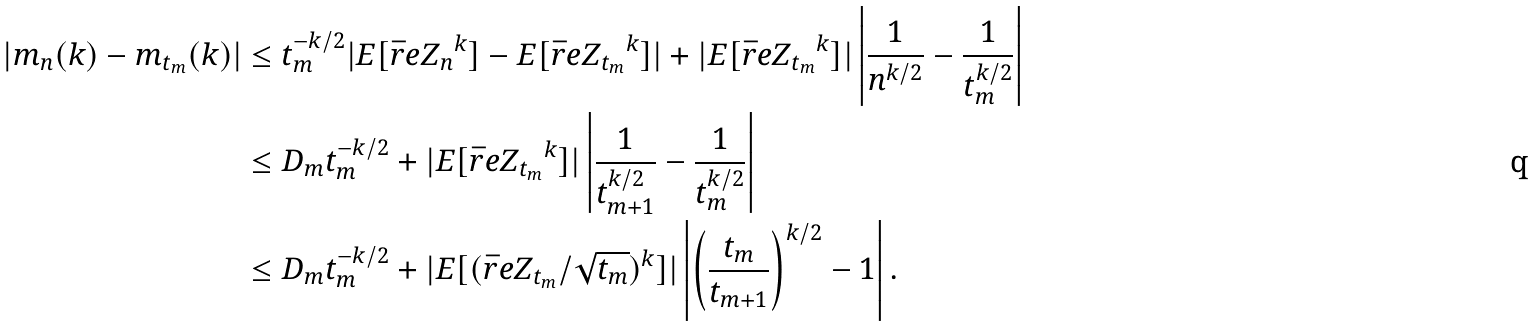Convert formula to latex. <formula><loc_0><loc_0><loc_500><loc_500>| m _ { n } ( k ) - m _ { t _ { m } } ( k ) | & \leq t _ { m } ^ { - k / 2 } | E [ \bar { r } e { Z _ { n } } ^ { k } ] - E [ \bar { r } e { Z _ { t _ { m } } } ^ { k } ] | + | E [ \bar { r } e { Z _ { t _ { m } } } ^ { k } ] | \left | \frac { 1 } { n ^ { k / 2 } } - \frac { 1 } { t _ { m } ^ { k / 2 } } \right | \\ & \leq D _ { m } t _ { m } ^ { - k / 2 } + | E [ \bar { r } e { Z _ { t _ { m } } } ^ { k } ] | \left | \frac { 1 } { t _ { m + 1 } ^ { k / 2 } } - \frac { 1 } { t _ { m } ^ { k / 2 } } \right | \\ & \leq D _ { m } t _ { m } ^ { - k / 2 } + | E [ ( \bar { r } e { Z _ { t _ { m } } } / \sqrt { t _ { m } } ) ^ { k } ] | \left | \left ( \frac { t _ { m } } { t _ { m + 1 } } \right ) ^ { k / 2 } - 1 \right | .</formula> 